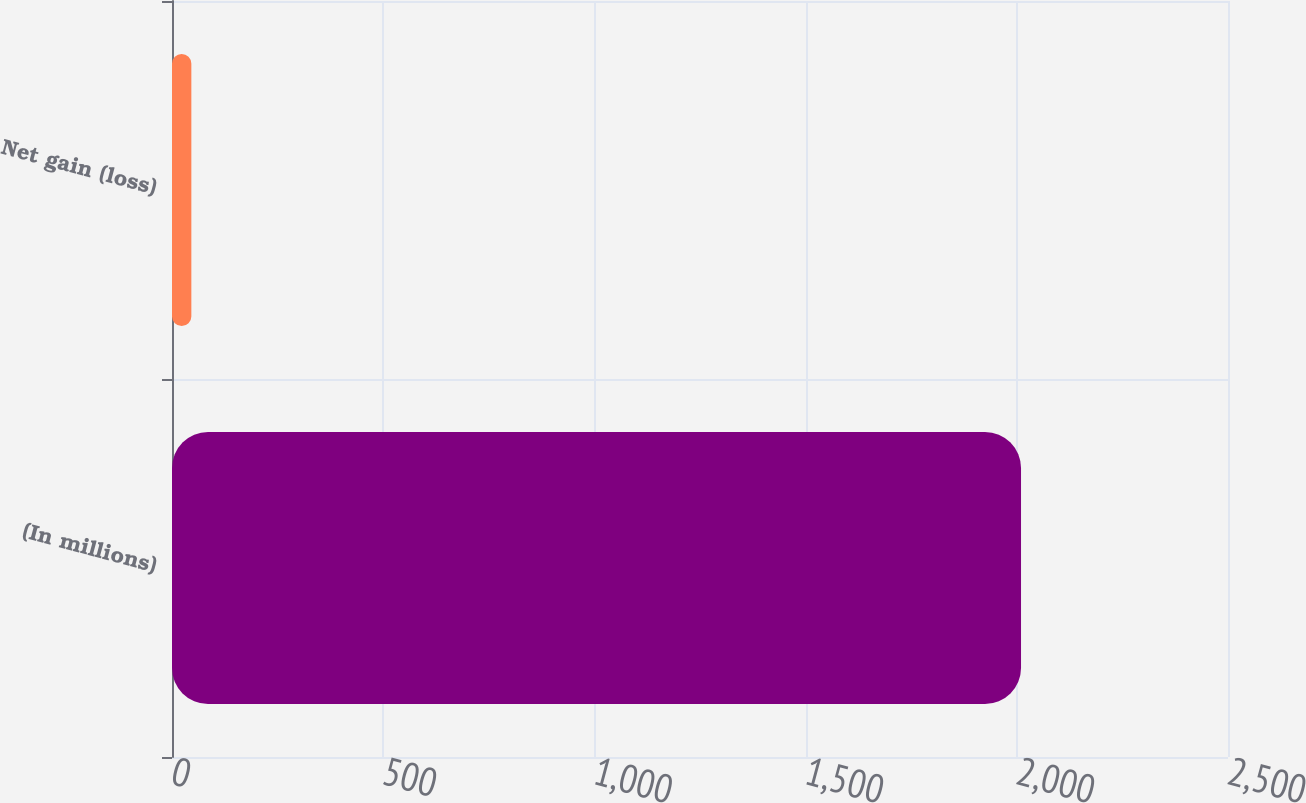<chart> <loc_0><loc_0><loc_500><loc_500><bar_chart><fcel>(In millions)<fcel>Net gain (loss)<nl><fcel>2010<fcel>45.8<nl></chart> 